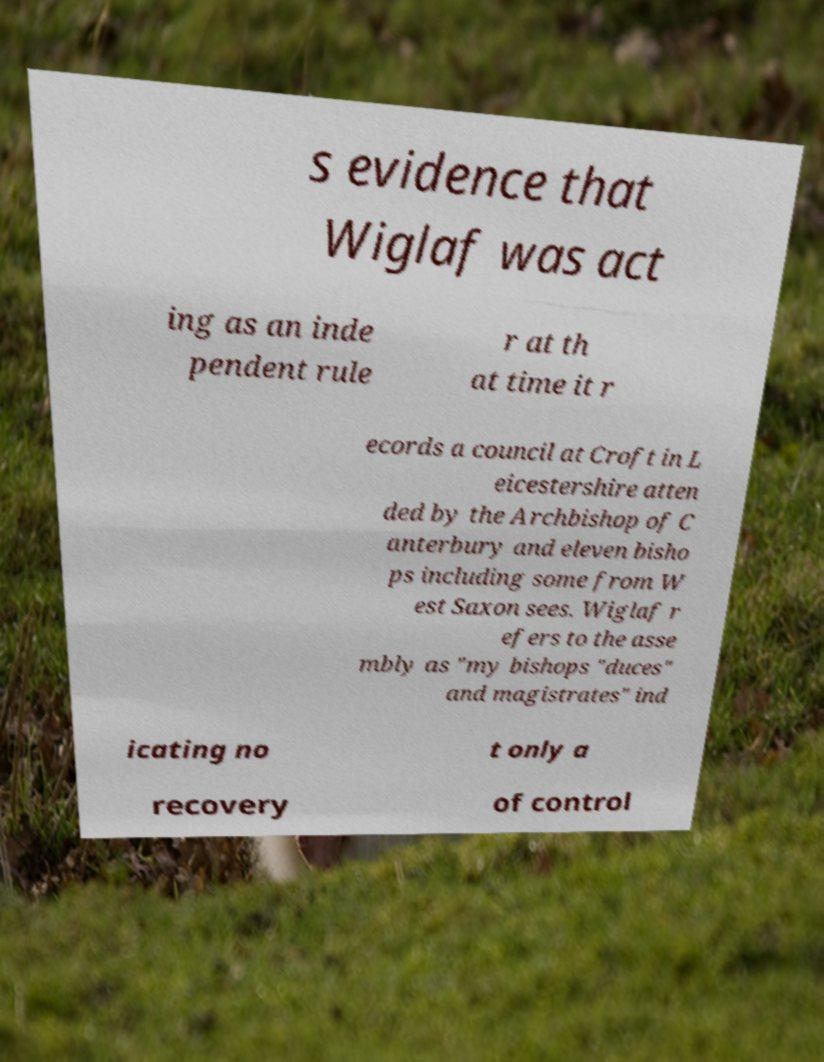Could you assist in decoding the text presented in this image and type it out clearly? s evidence that Wiglaf was act ing as an inde pendent rule r at th at time it r ecords a council at Croft in L eicestershire atten ded by the Archbishop of C anterbury and eleven bisho ps including some from W est Saxon sees. Wiglaf r efers to the asse mbly as "my bishops "duces" and magistrates" ind icating no t only a recovery of control 